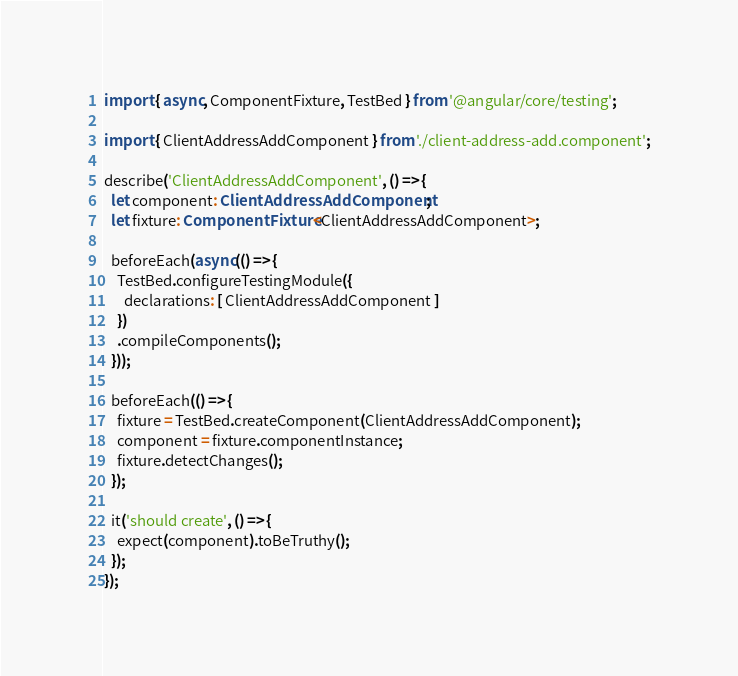<code> <loc_0><loc_0><loc_500><loc_500><_TypeScript_>import { async, ComponentFixture, TestBed } from '@angular/core/testing';

import { ClientAddressAddComponent } from './client-address-add.component';

describe('ClientAddressAddComponent', () => {
  let component: ClientAddressAddComponent;
  let fixture: ComponentFixture<ClientAddressAddComponent>;

  beforeEach(async(() => {
    TestBed.configureTestingModule({
      declarations: [ ClientAddressAddComponent ]
    })
    .compileComponents();
  }));

  beforeEach(() => {
    fixture = TestBed.createComponent(ClientAddressAddComponent);
    component = fixture.componentInstance;
    fixture.detectChanges();
  });

  it('should create', () => {
    expect(component).toBeTruthy();
  });
});
</code> 